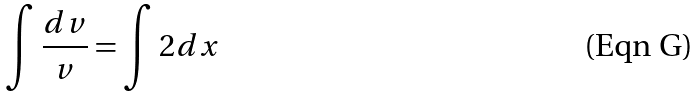<formula> <loc_0><loc_0><loc_500><loc_500>\int \frac { d v } { v } = \int 2 d x</formula> 